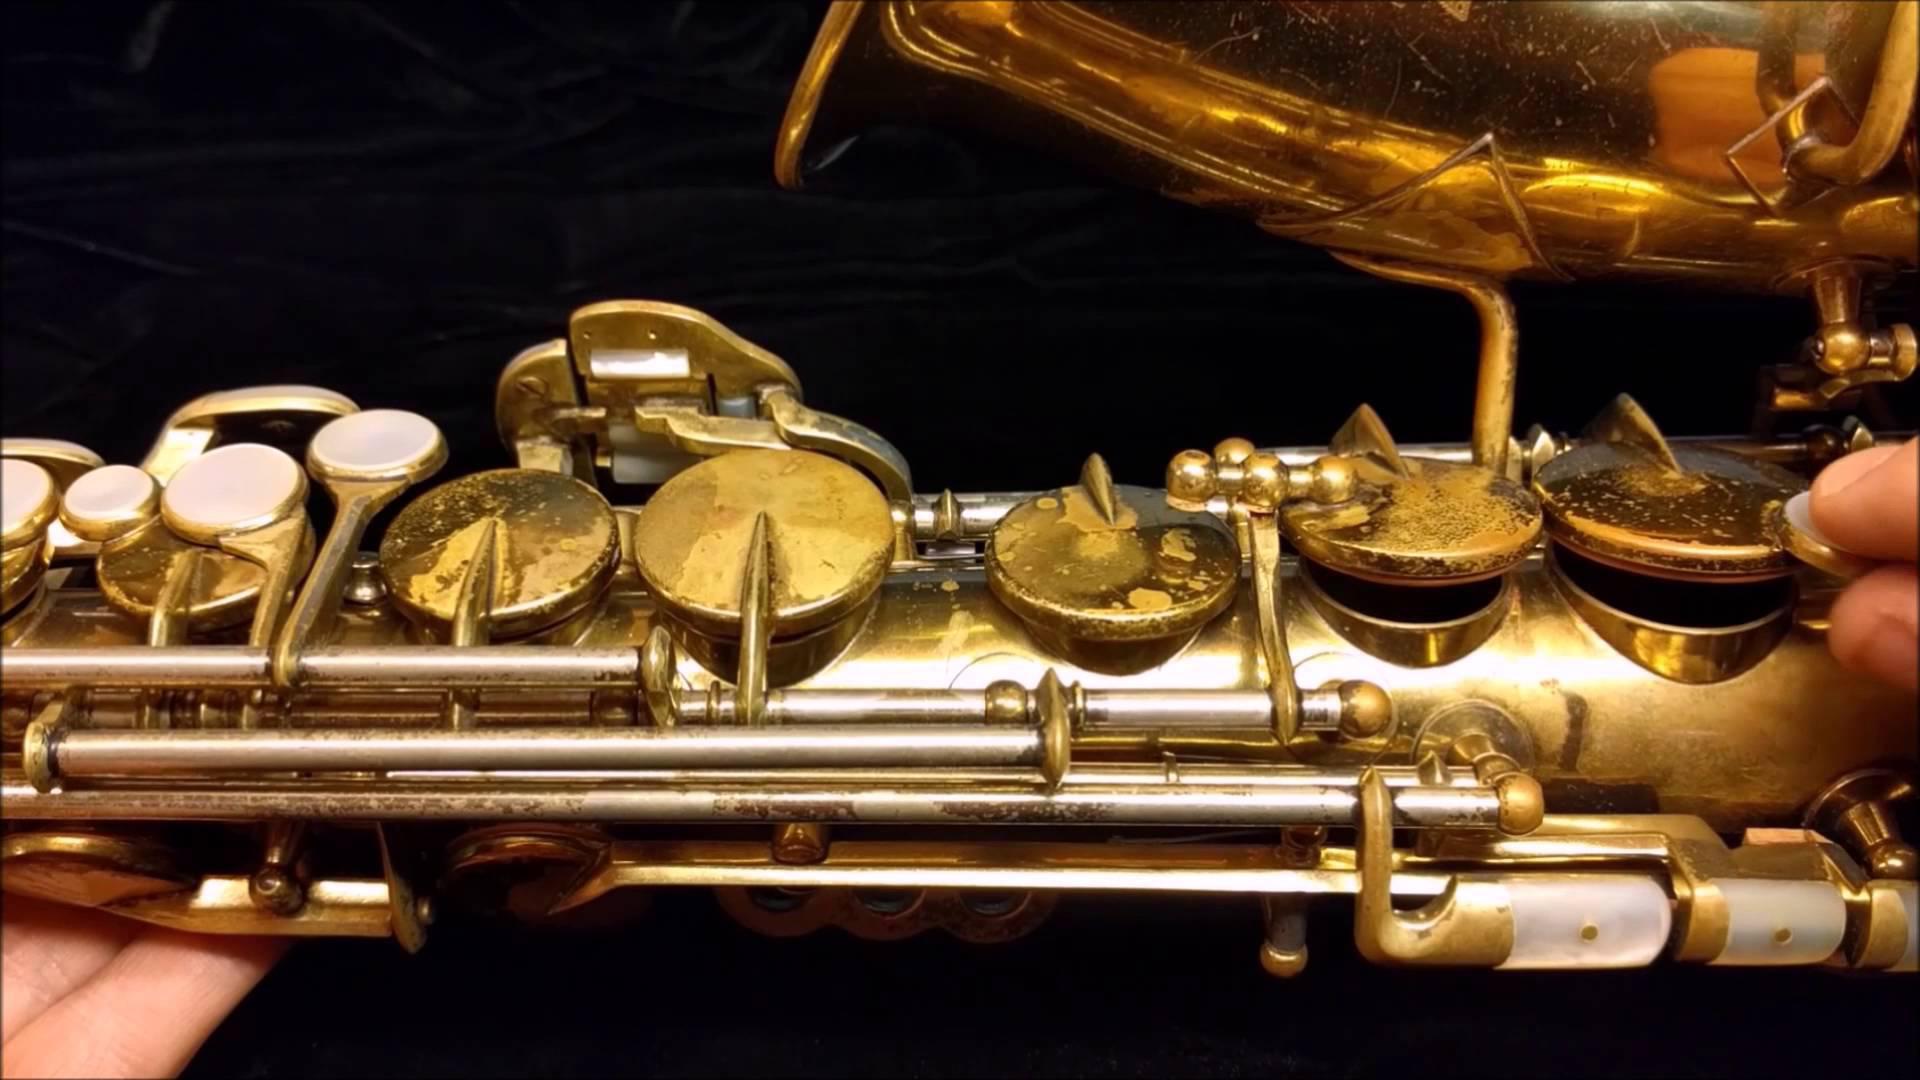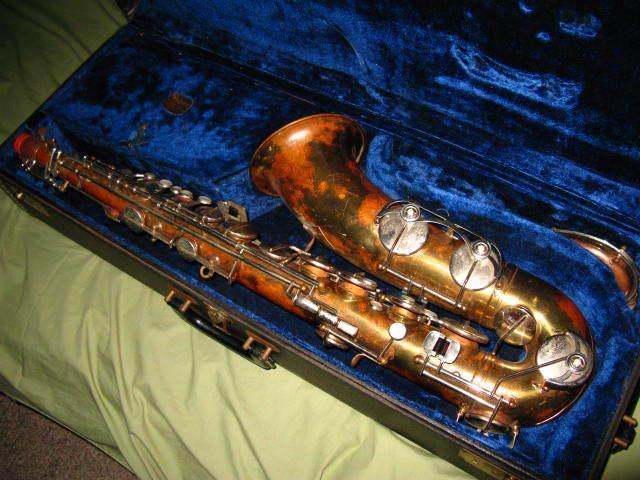The first image is the image on the left, the second image is the image on the right. Assess this claim about the two images: "An image shows a saxophone with a mottled finish, displayed in an open plush-lined case.". Correct or not? Answer yes or no. Yes. The first image is the image on the left, the second image is the image on the right. For the images shown, is this caption "A saxophone in one image is positioned inside a dark blue lined case, while a second image shows a section of the gold keys of another saxophone." true? Answer yes or no. Yes. 